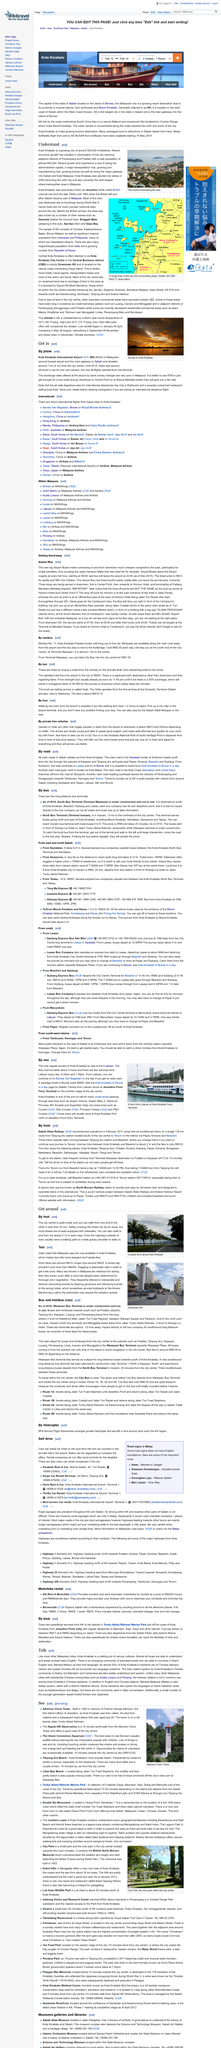Outline some significant characteristics in this image. It is possible to travel to KK by private car, and many visitors choose to do so. The pricing of a tour to the Kinabalu National Park, which is a World Heritage site, is determined by several factors, including the time of the season and fuel prices. Kota Kinabalu International Airport is the main gateway to the place of Sabah. To hire a taxi service, customers must purchase a ticket at the landing level window and then present it to the driver. I am a researcher and I conducted a study to investigate the exchange rates offered by bank money changers at the Kota Kinabalu International Airport. The results of my study show that the exchange rates offered by these bank money changers are indeed very poor. The evidence suggests that these rates are significantly lower than the interbank rates and other money changers in the area. Therefore, I can confidently say that the exchange rates offered by bank money changers at the Kota Kinabalu International Airport are very poor. 